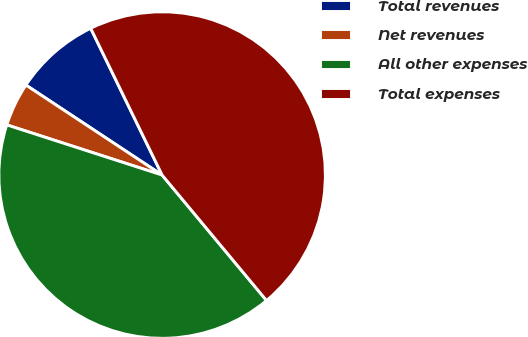Convert chart to OTSL. <chart><loc_0><loc_0><loc_500><loc_500><pie_chart><fcel>Total revenues<fcel>Net revenues<fcel>All other expenses<fcel>Total expenses<nl><fcel>8.5%<fcel>4.32%<fcel>41.02%<fcel>46.16%<nl></chart> 